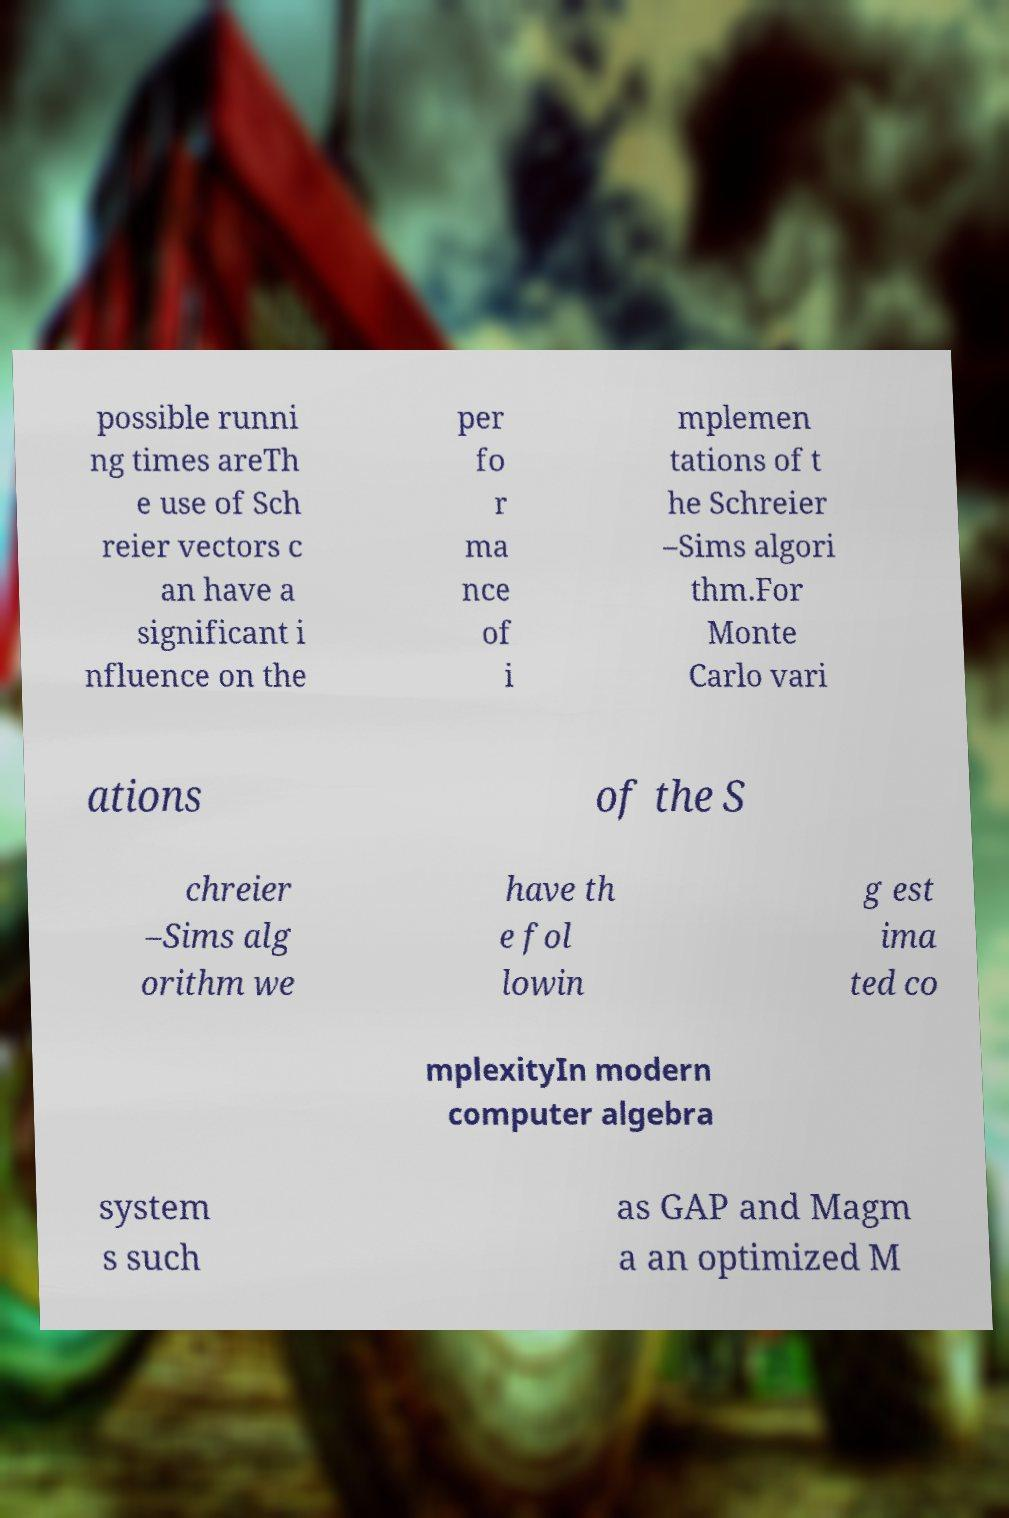There's text embedded in this image that I need extracted. Can you transcribe it verbatim? possible runni ng times areTh e use of Sch reier vectors c an have a significant i nfluence on the per fo r ma nce of i mplemen tations of t he Schreier –Sims algori thm.For Monte Carlo vari ations of the S chreier –Sims alg orithm we have th e fol lowin g est ima ted co mplexityIn modern computer algebra system s such as GAP and Magm a an optimized M 